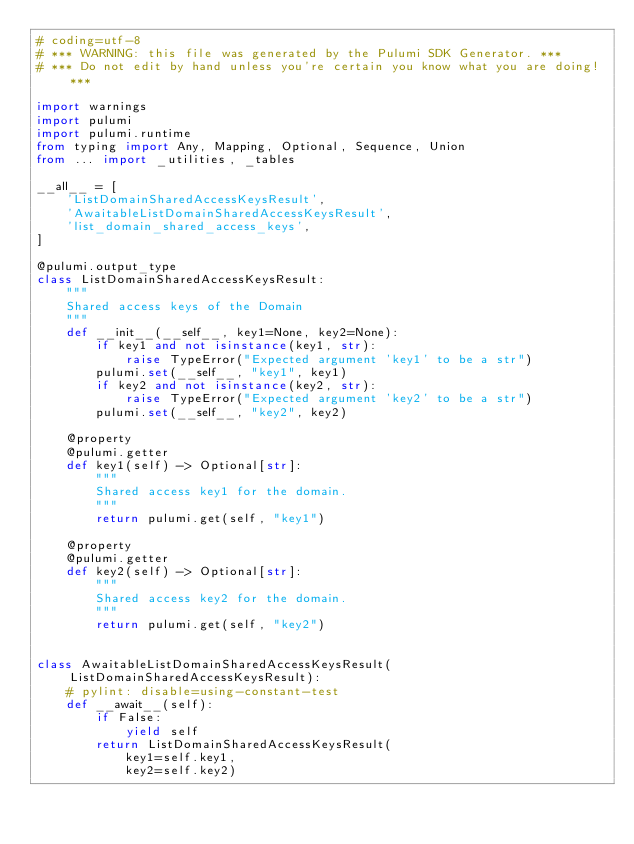Convert code to text. <code><loc_0><loc_0><loc_500><loc_500><_Python_># coding=utf-8
# *** WARNING: this file was generated by the Pulumi SDK Generator. ***
# *** Do not edit by hand unless you're certain you know what you are doing! ***

import warnings
import pulumi
import pulumi.runtime
from typing import Any, Mapping, Optional, Sequence, Union
from ... import _utilities, _tables

__all__ = [
    'ListDomainSharedAccessKeysResult',
    'AwaitableListDomainSharedAccessKeysResult',
    'list_domain_shared_access_keys',
]

@pulumi.output_type
class ListDomainSharedAccessKeysResult:
    """
    Shared access keys of the Domain
    """
    def __init__(__self__, key1=None, key2=None):
        if key1 and not isinstance(key1, str):
            raise TypeError("Expected argument 'key1' to be a str")
        pulumi.set(__self__, "key1", key1)
        if key2 and not isinstance(key2, str):
            raise TypeError("Expected argument 'key2' to be a str")
        pulumi.set(__self__, "key2", key2)

    @property
    @pulumi.getter
    def key1(self) -> Optional[str]:
        """
        Shared access key1 for the domain.
        """
        return pulumi.get(self, "key1")

    @property
    @pulumi.getter
    def key2(self) -> Optional[str]:
        """
        Shared access key2 for the domain.
        """
        return pulumi.get(self, "key2")


class AwaitableListDomainSharedAccessKeysResult(ListDomainSharedAccessKeysResult):
    # pylint: disable=using-constant-test
    def __await__(self):
        if False:
            yield self
        return ListDomainSharedAccessKeysResult(
            key1=self.key1,
            key2=self.key2)

</code> 